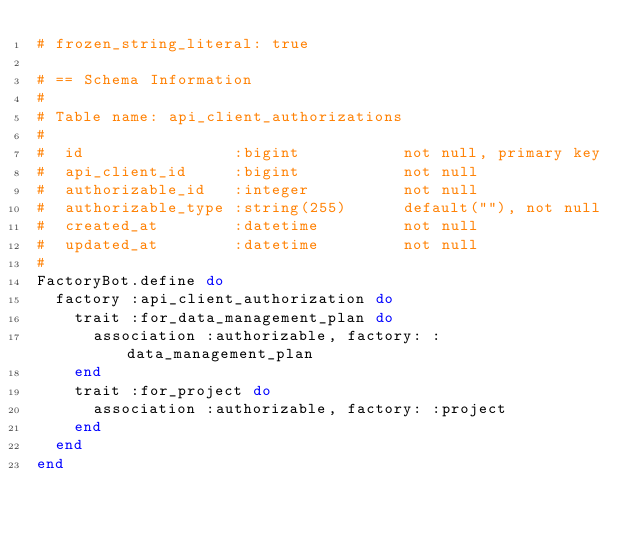Convert code to text. <code><loc_0><loc_0><loc_500><loc_500><_Ruby_># frozen_string_literal: true

# == Schema Information
#
# Table name: api_client_authorizations
#
#  id                :bigint           not null, primary key
#  api_client_id     :bigint           not null
#  authorizable_id   :integer          not null
#  authorizable_type :string(255)      default(""), not null
#  created_at        :datetime         not null
#  updated_at        :datetime         not null
#
FactoryBot.define do
  factory :api_client_authorization do
    trait :for_data_management_plan do
      association :authorizable, factory: :data_management_plan
    end
    trait :for_project do
      association :authorizable, factory: :project
    end
  end
end
</code> 